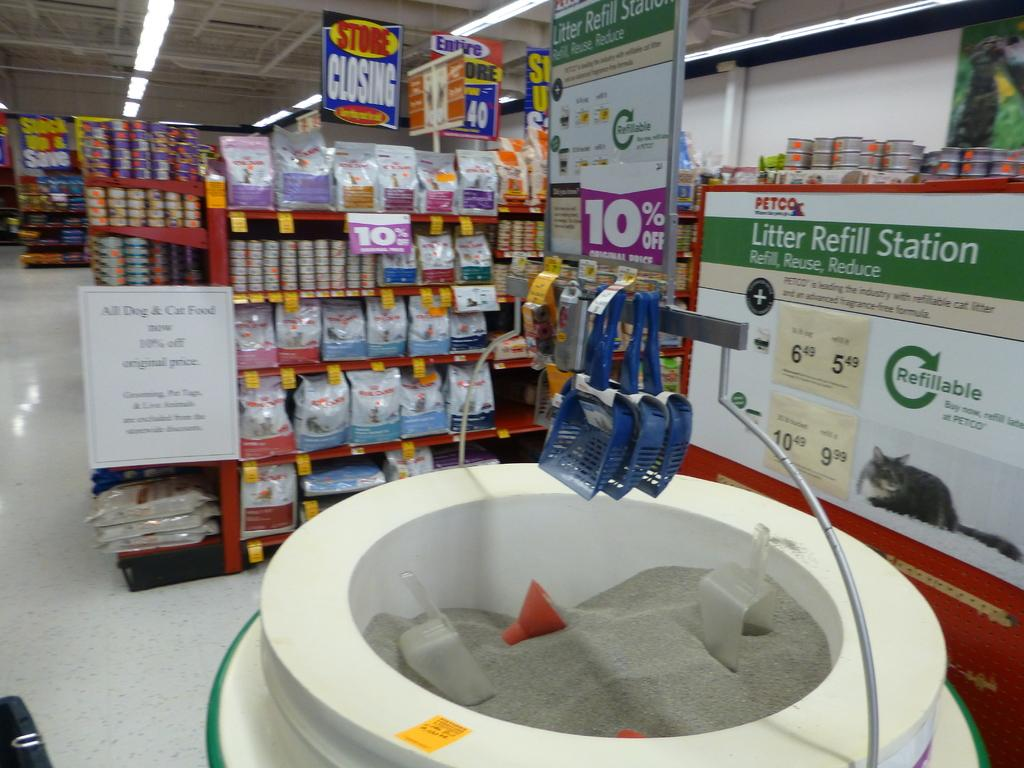<image>
Share a concise interpretation of the image provided. A sign on the wall says this is the litter refill station at Petco. 